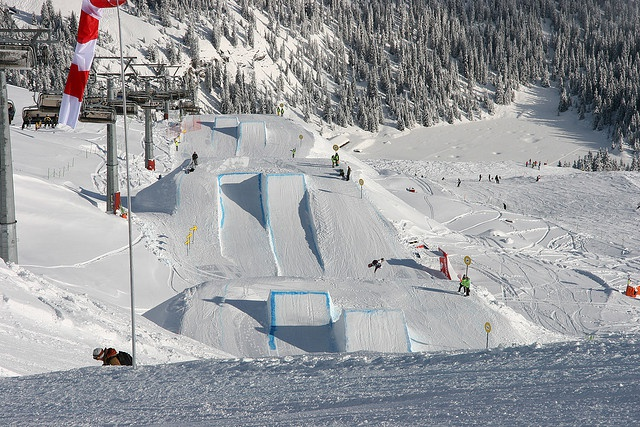Describe the objects in this image and their specific colors. I can see people in lightgray, black, maroon, and gray tones, people in lightgray, black, gray, and darkgray tones, people in lightgray, black, green, and gray tones, people in lightgray, black, darkgray, and gray tones, and people in lightgray, black, green, gray, and darkgray tones in this image. 